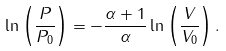Convert formula to latex. <formula><loc_0><loc_0><loc_500><loc_500>\ln \left ( { \frac { P } { P _ { 0 } } } \right ) = - { \frac { \alpha + 1 } { \alpha } } \ln \left ( { \frac { V } { V _ { 0 } } } \right ) .</formula> 